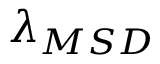Convert formula to latex. <formula><loc_0><loc_0><loc_500><loc_500>\lambda _ { M S D }</formula> 